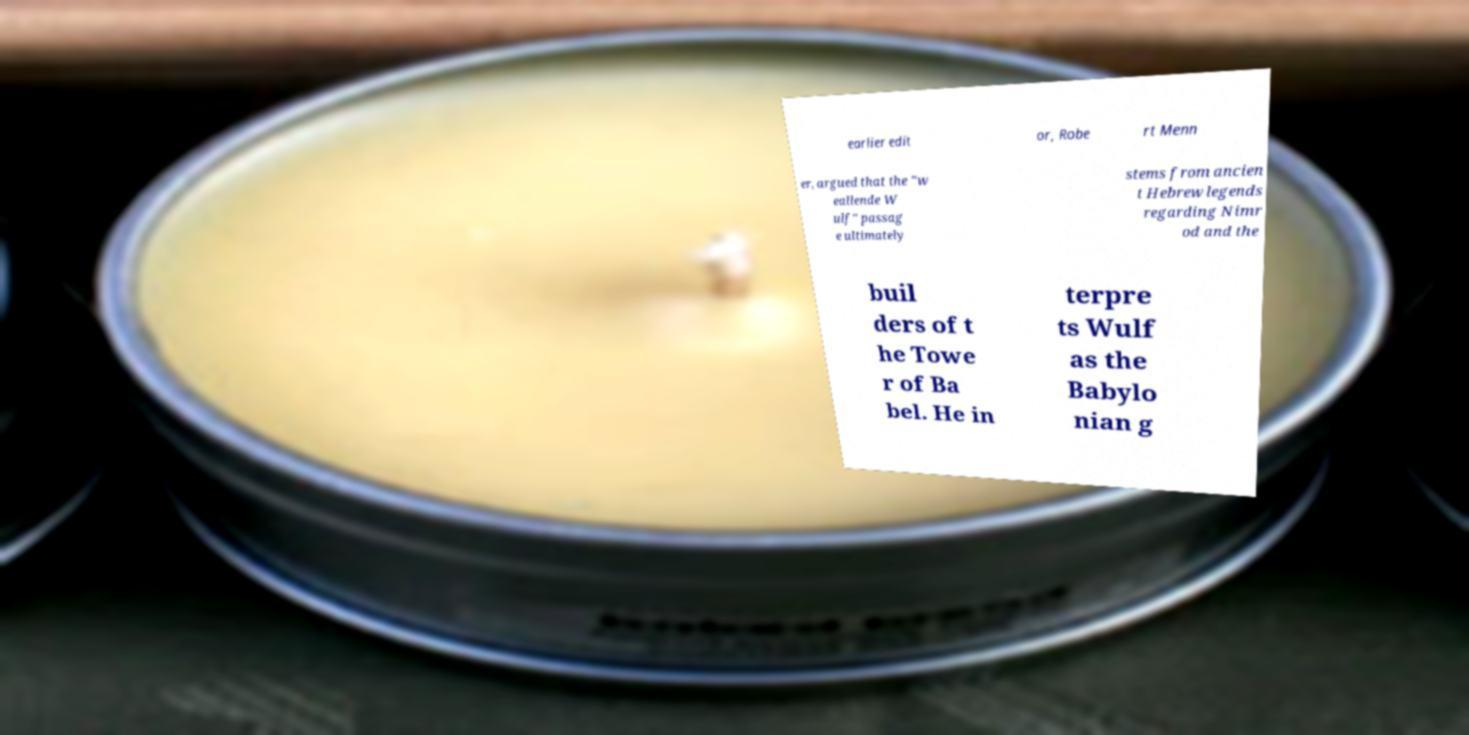Please read and relay the text visible in this image. What does it say? earlier edit or, Robe rt Menn er, argued that the "w eallende W ulf" passag e ultimately stems from ancien t Hebrew legends regarding Nimr od and the buil ders of t he Towe r of Ba bel. He in terpre ts Wulf as the Babylo nian g 